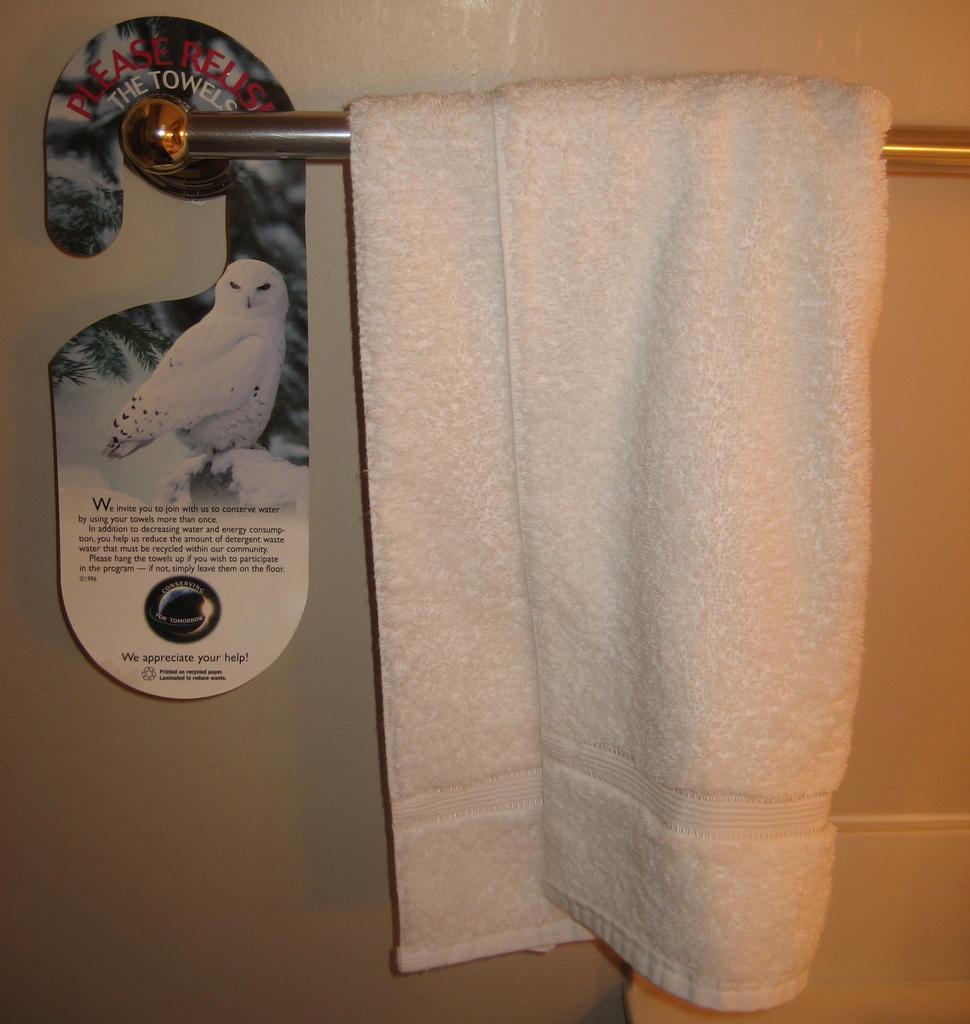How would you summarize this image in a sentence or two? In this image I can see a towel hanging on the rod. On the left side I can see a board with some text written on it. In the background, I can see the wall. 